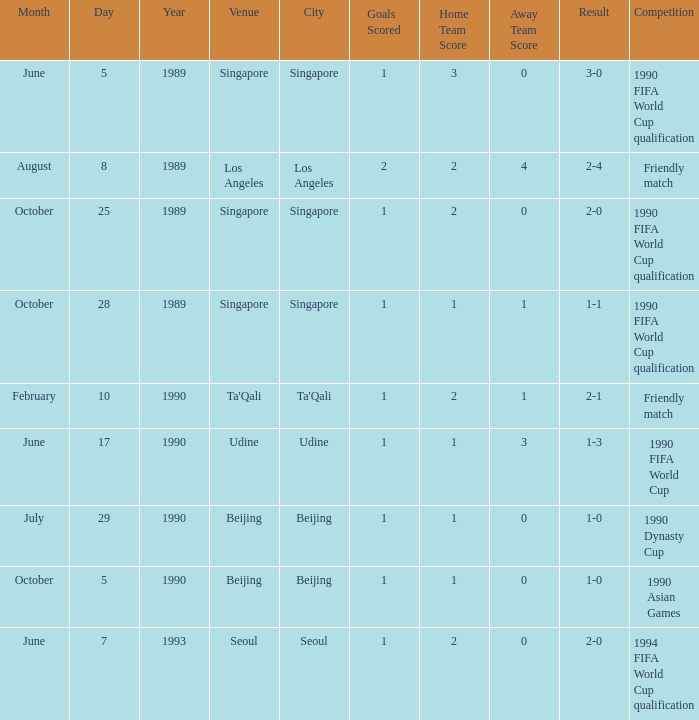What was the score of the match with a 3-0 result? 1 goal. 